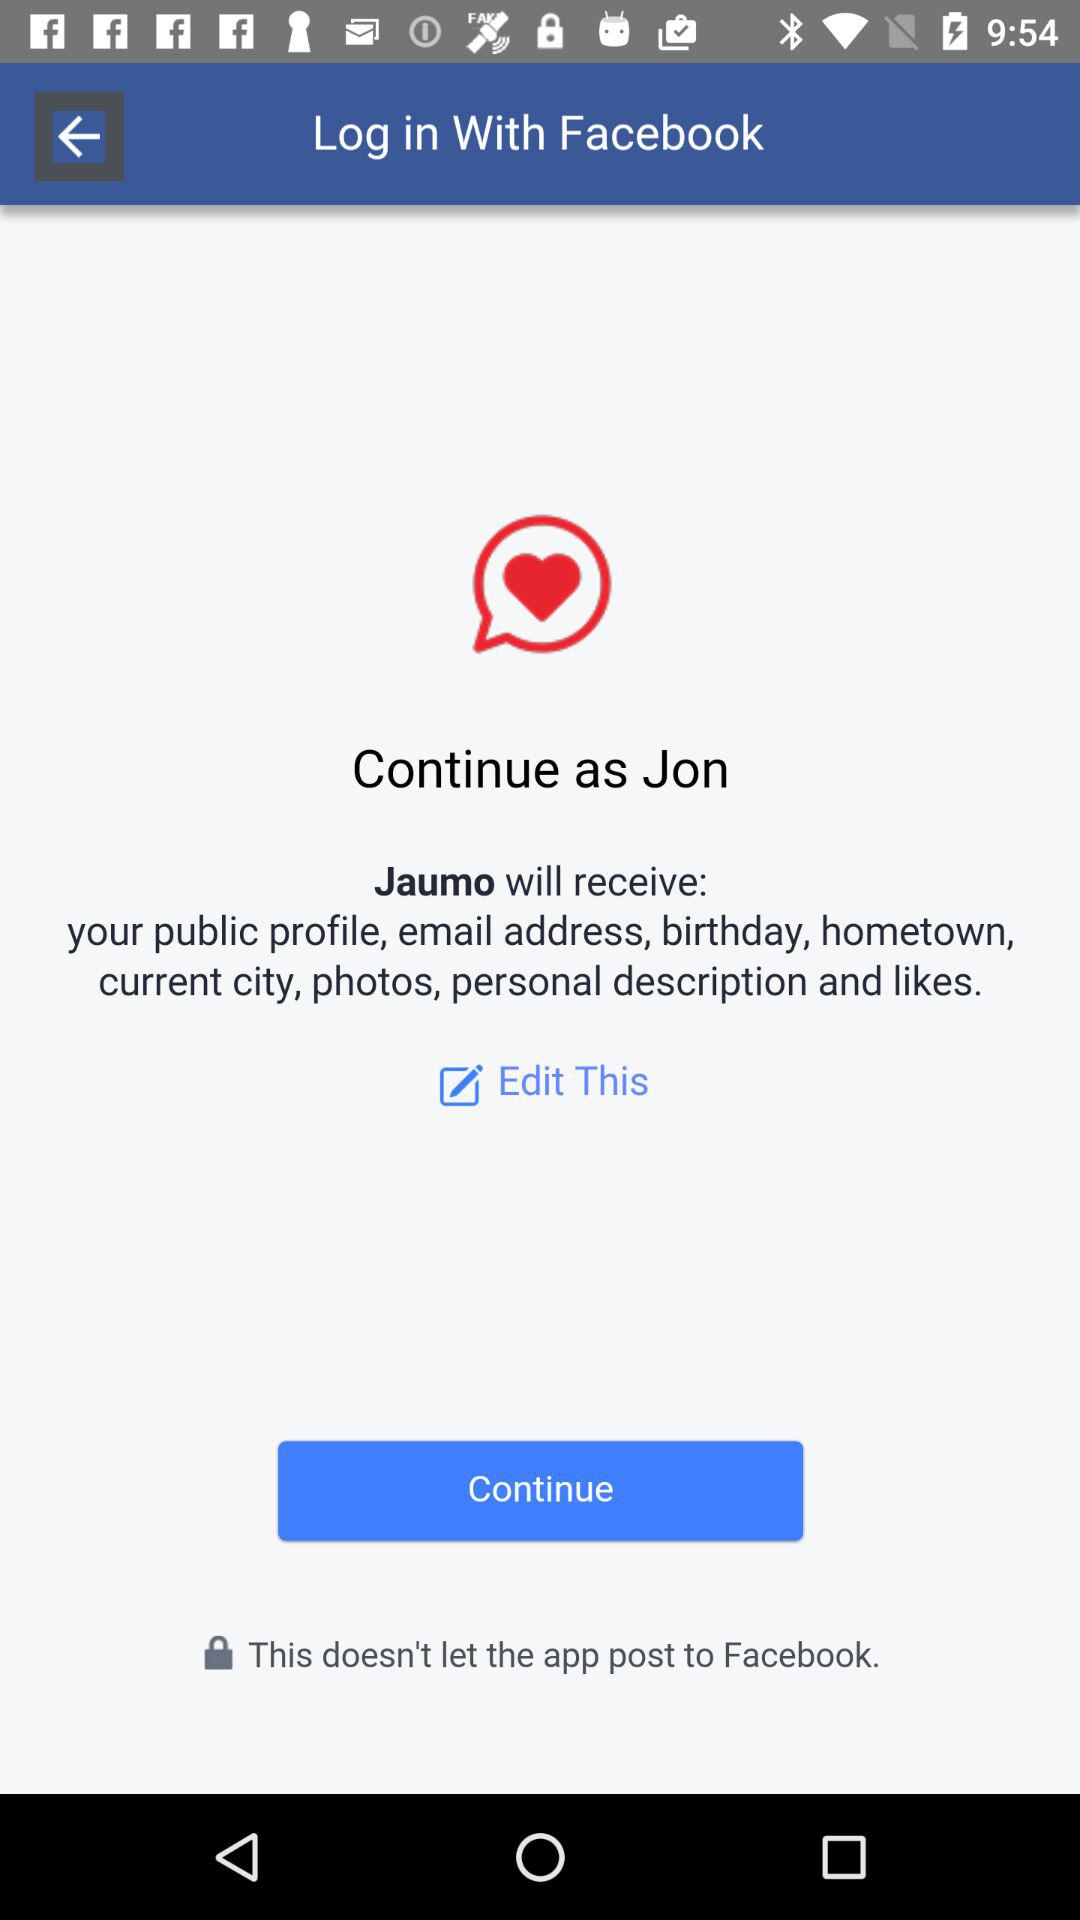What is the name of the user? The name of the user is Jon. 